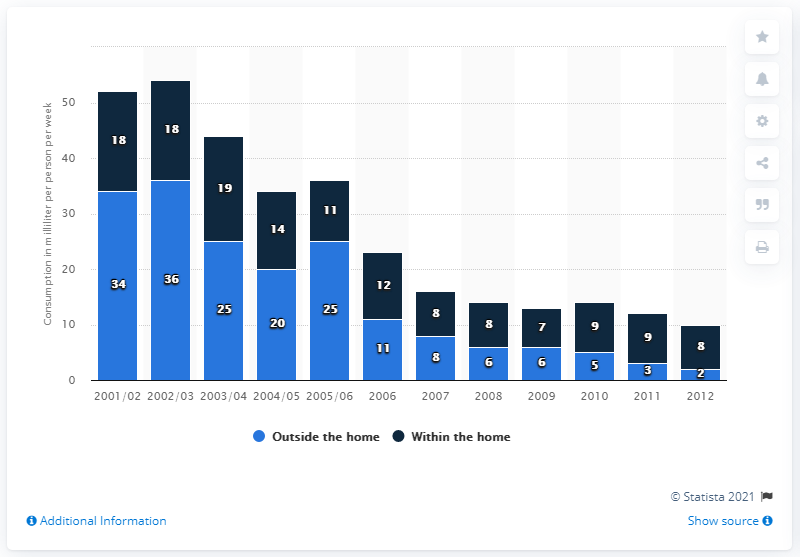Mention a couple of crucial points in this snapshot. In 2006, a total of 12 milliliters of alcopops were consumed within the home. In 2006, the average person consumed 11 milliliters of alcopops per week outside of their home. 